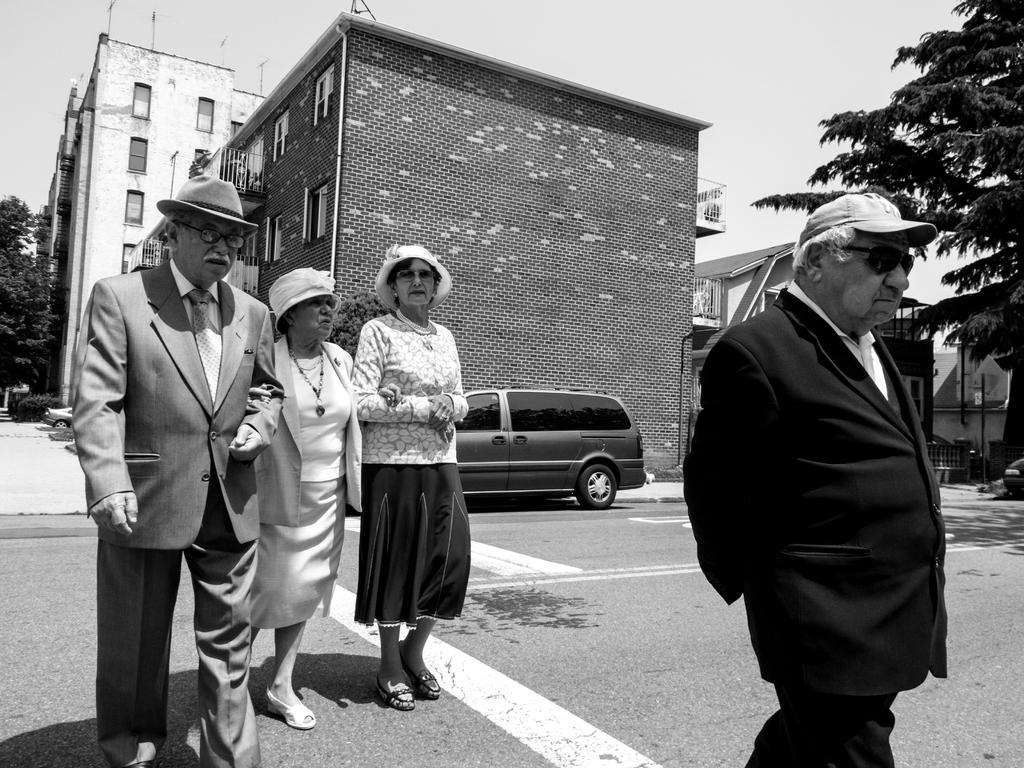What is the color scheme of the image? The image is black and white. What type of structures can be seen in the image? There are buildings in the image. What else is present in the image besides buildings? There are vehicles, poles, plants, trees, and people in the image. What is visible in the background of the image? The sky is visible in the image. What are the people in the image wearing on their heads? The people are wearing hats or caps in the image. What type of pathway is present in the image? There is a road in the image. How many hands are visible in the image? There is no mention of hands in the provided facts, so it is impossible to determine the number of hands visible in the image. 